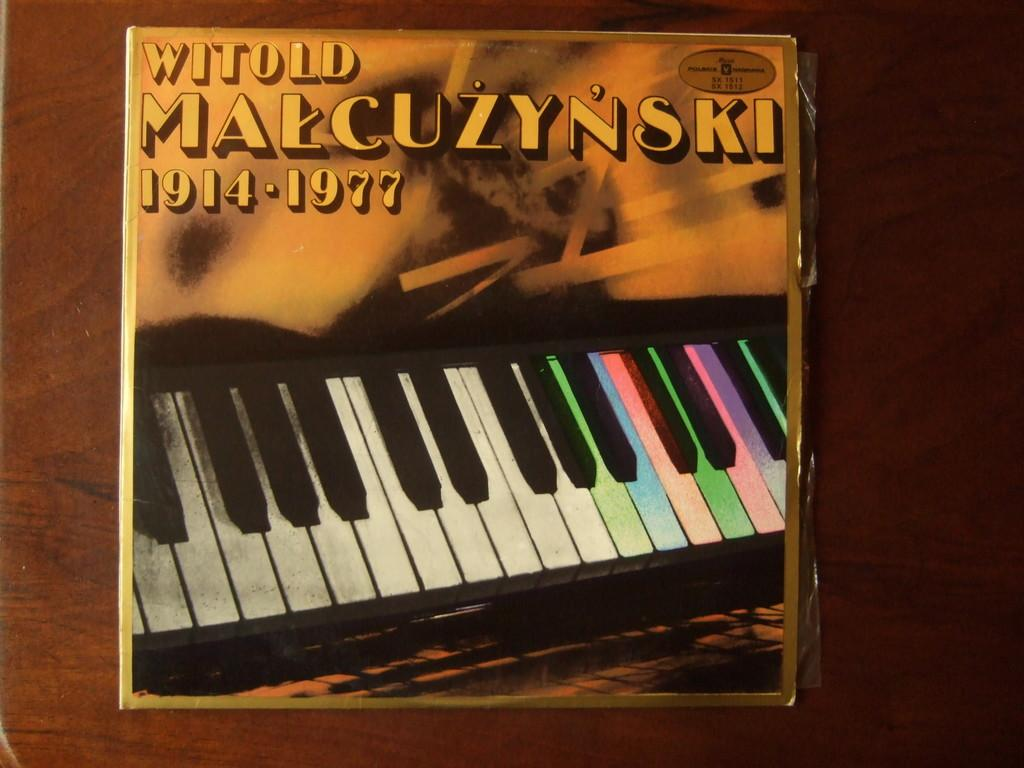What is the main object in the image? There is a card in the image. What is the card placed on? The card is placed on a wooden surface. What is depicted on the card? The card has a picture of a piano. Are there any words or letters on the card? Yes, there is text on the card. How does the guitar fall off the card in the image? There is no guitar present in the image, and therefore it cannot fall off the card. 